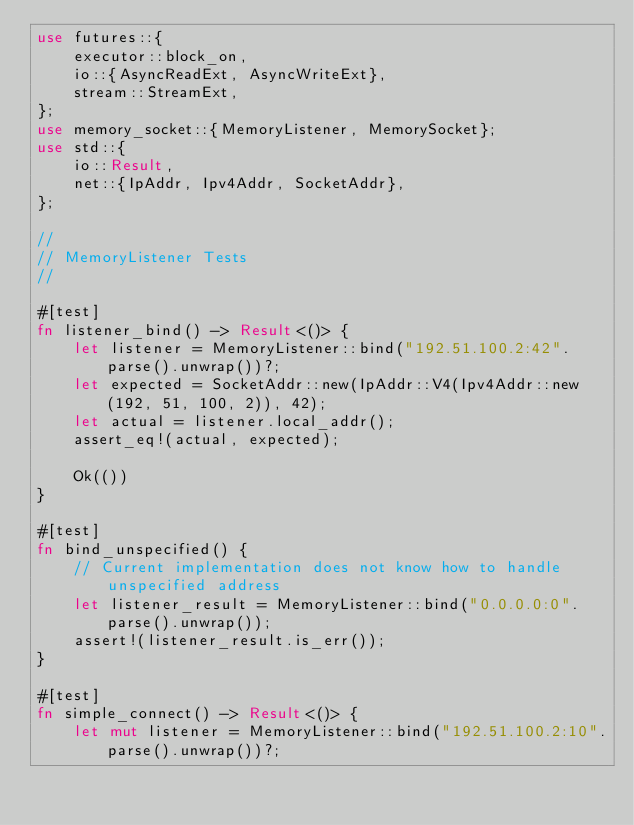Convert code to text. <code><loc_0><loc_0><loc_500><loc_500><_Rust_>use futures::{
    executor::block_on,
    io::{AsyncReadExt, AsyncWriteExt},
    stream::StreamExt,
};
use memory_socket::{MemoryListener, MemorySocket};
use std::{
    io::Result,
    net::{IpAddr, Ipv4Addr, SocketAddr},
};

//
// MemoryListener Tests
//

#[test]
fn listener_bind() -> Result<()> {
    let listener = MemoryListener::bind("192.51.100.2:42".parse().unwrap())?;
    let expected = SocketAddr::new(IpAddr::V4(Ipv4Addr::new(192, 51, 100, 2)), 42);
    let actual = listener.local_addr();
    assert_eq!(actual, expected);

    Ok(())
}

#[test]
fn bind_unspecified() {
    // Current implementation does not know how to handle unspecified address
    let listener_result = MemoryListener::bind("0.0.0.0:0".parse().unwrap());
    assert!(listener_result.is_err());
}

#[test]
fn simple_connect() -> Result<()> {
    let mut listener = MemoryListener::bind("192.51.100.2:10".parse().unwrap())?;
</code> 